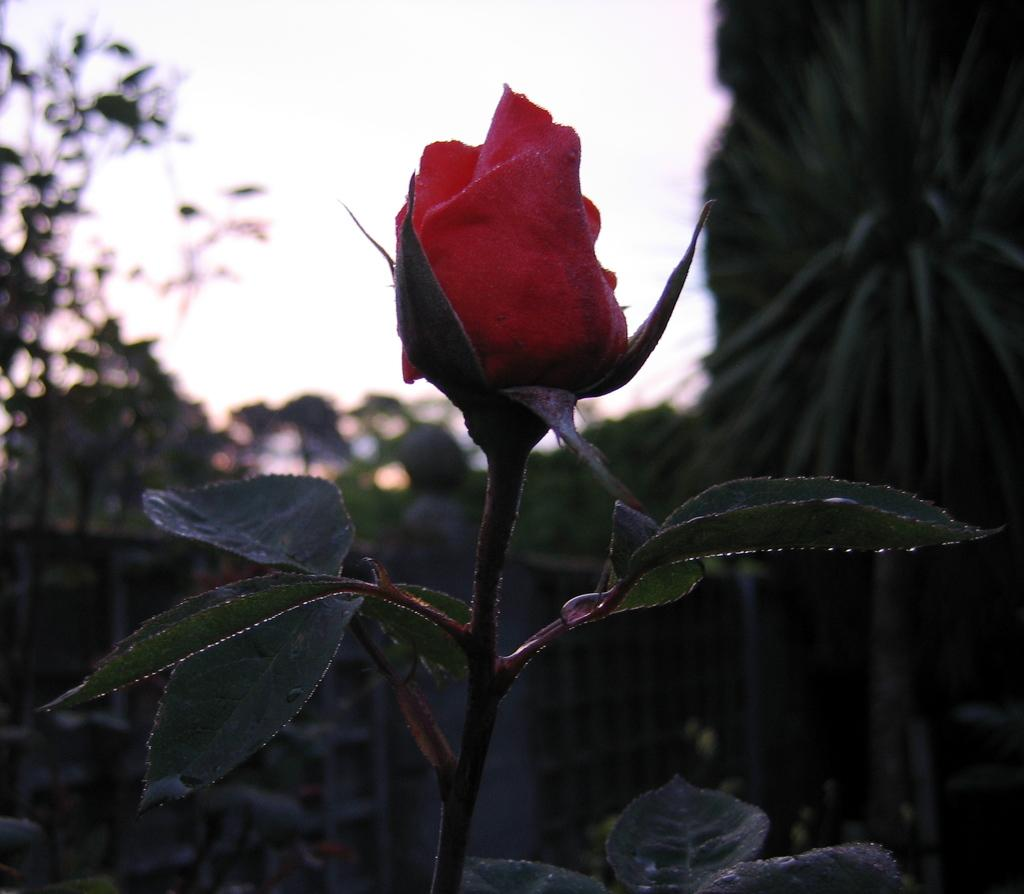What is the main subject of the image? The main subject of the image is a bud. What other elements are present in the image? There are flowers, leaves, and a stem in the image. How would you describe the background of the image? The background of the image is blurred. What type of paste is being used to write a note in the image? There is no paste or note present in the image; it features a bud, flowers, leaves, and a stem with a blurred background. 